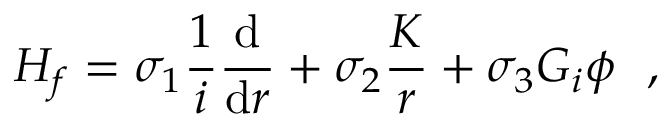<formula> <loc_0><loc_0><loc_500><loc_500>H _ { f } = \sigma _ { 1 } \frac { 1 } { i } \frac { d } { d r } + \sigma _ { 2 } \frac { K } { r } + \sigma _ { 3 } G _ { i } \phi ,</formula> 